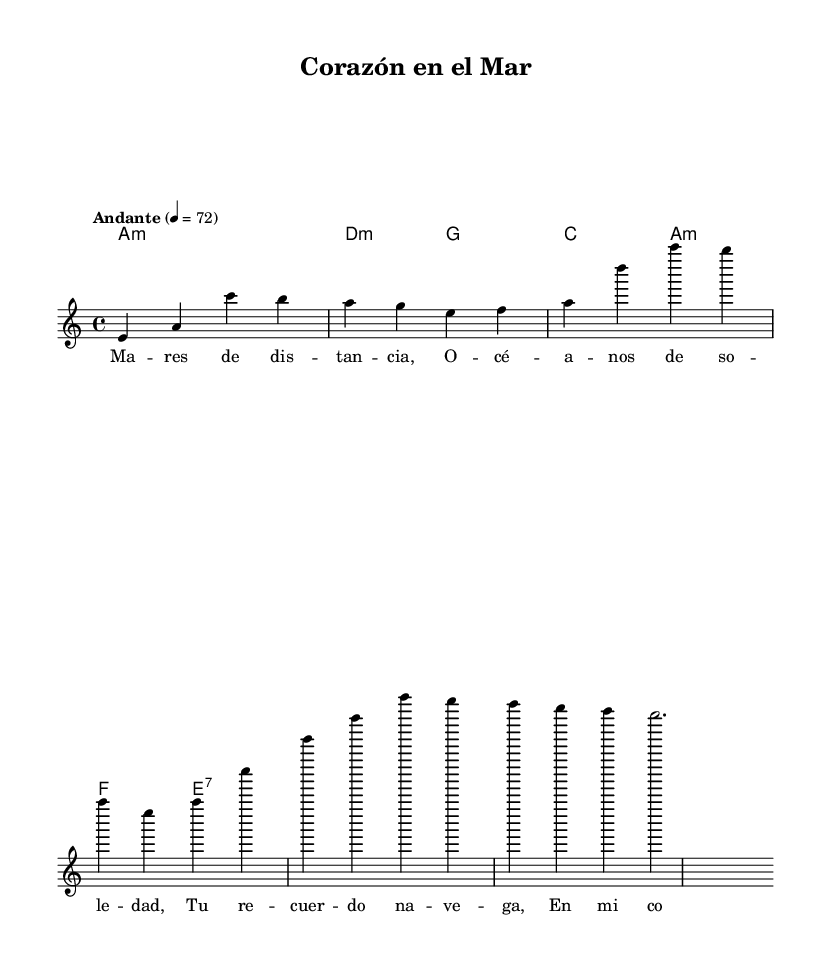What is the key signature of this piece? The key signature is A minor, which has no sharps or flats, indicated at the beginning of the staff.
Answer: A minor What is the time signature of this piece? The time signature is 4/4, which means there are four beats in each measure and the quarter note gets one beat, clearly noted at the beginning of the staff.
Answer: 4/4 What is the tempo marking for this composition? The tempo marking is "Andante", which indicates a moderate pace, shown at the beginning of the score with a metronome marking of 72.
Answer: Andante How many measures are in the melody section? By counting the number of complete measures in the melody line, we find there are four measures total.
Answer: 4 What chord follows the A minor in the harmony progression? The chord that follows A minor in the provided harmony progression is D minor, as indicated in the chord mode section that outlines the sequence of chords.
Answer: D minor What is the main theme according to the lyrics? The theme expressed in the lyrics revolves around the feelings of distance and loneliness, specifically mentioning memories and a longing for connection, as described in the lyrical content.
Answer: Distance and loneliness What type of song structure is used in this piece? The piece employs a verse-chorus structure common in ballads, featuring a lyrical verse which is reflective of personal emotions related to distance in relationships.
Answer: Verse-chorus 